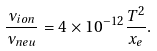<formula> <loc_0><loc_0><loc_500><loc_500>\frac { \nu _ { i o n } } { \nu _ { n e u } } = 4 \times 1 0 ^ { - 1 2 } \frac { T ^ { 2 } } { x _ { e } } .</formula> 